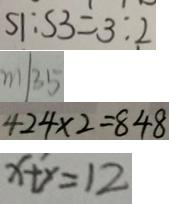Convert formula to latex. <formula><loc_0><loc_0><loc_500><loc_500>S 1 : S 3 = 3 : 2 
 m \vert 3 5 
 4 2 4 \times 2 = 8 4 8 
 x + y = 1 2</formula> 